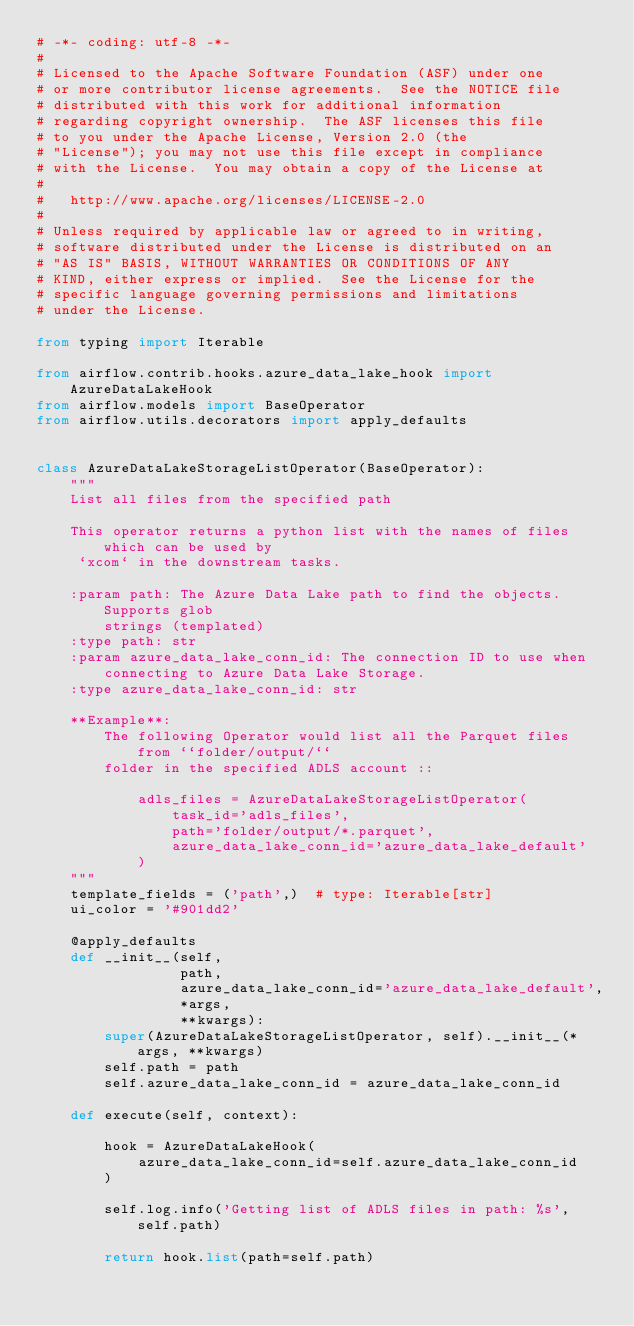Convert code to text. <code><loc_0><loc_0><loc_500><loc_500><_Python_># -*- coding: utf-8 -*-
#
# Licensed to the Apache Software Foundation (ASF) under one
# or more contributor license agreements.  See the NOTICE file
# distributed with this work for additional information
# regarding copyright ownership.  The ASF licenses this file
# to you under the Apache License, Version 2.0 (the
# "License"); you may not use this file except in compliance
# with the License.  You may obtain a copy of the License at
#
#   http://www.apache.org/licenses/LICENSE-2.0
#
# Unless required by applicable law or agreed to in writing,
# software distributed under the License is distributed on an
# "AS IS" BASIS, WITHOUT WARRANTIES OR CONDITIONS OF ANY
# KIND, either express or implied.  See the License for the
# specific language governing permissions and limitations
# under the License.

from typing import Iterable

from airflow.contrib.hooks.azure_data_lake_hook import AzureDataLakeHook
from airflow.models import BaseOperator
from airflow.utils.decorators import apply_defaults


class AzureDataLakeStorageListOperator(BaseOperator):
    """
    List all files from the specified path

    This operator returns a python list with the names of files which can be used by
     `xcom` in the downstream tasks.

    :param path: The Azure Data Lake path to find the objects. Supports glob
        strings (templated)
    :type path: str
    :param azure_data_lake_conn_id: The connection ID to use when
        connecting to Azure Data Lake Storage.
    :type azure_data_lake_conn_id: str

    **Example**:
        The following Operator would list all the Parquet files from ``folder/output/``
        folder in the specified ADLS account ::

            adls_files = AzureDataLakeStorageListOperator(
                task_id='adls_files',
                path='folder/output/*.parquet',
                azure_data_lake_conn_id='azure_data_lake_default'
            )
    """
    template_fields = ('path',)  # type: Iterable[str]
    ui_color = '#901dd2'

    @apply_defaults
    def __init__(self,
                 path,
                 azure_data_lake_conn_id='azure_data_lake_default',
                 *args,
                 **kwargs):
        super(AzureDataLakeStorageListOperator, self).__init__(*args, **kwargs)
        self.path = path
        self.azure_data_lake_conn_id = azure_data_lake_conn_id

    def execute(self, context):

        hook = AzureDataLakeHook(
            azure_data_lake_conn_id=self.azure_data_lake_conn_id
        )

        self.log.info('Getting list of ADLS files in path: %s', self.path)

        return hook.list(path=self.path)
</code> 